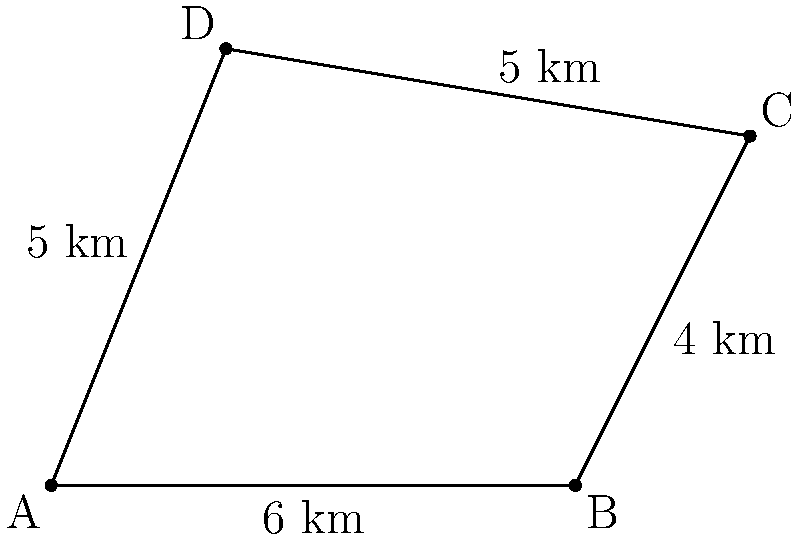An irregularly shaped land parcel for a potential airport expansion is represented by the quadrilateral ABCD in the diagram. Given that AB = 6 km, BC = 4 km, CD = 5 km, and DA = 5 km, calculate the area of this land parcel using the vector method. Round your answer to the nearest square kilometer. To calculate the area of the quadrilateral using the vector method, we'll follow these steps:

1) Choose a reference point (e.g., point A) and express other points as vectors from A:
   $\vec{AB} = (6,0)$
   $\vec{AC} = (8,4)$
   $\vec{AD} = (2,5)$

2) The area of a quadrilateral ABCD can be calculated using the formula:
   Area = $\frac{1}{2}|(\vec{AB} \times \vec{AC}) + (\vec{AC} \times \vec{AD})|$

3) Calculate the cross products:
   $\vec{AB} \times \vec{AC} = (6 \cdot 4) - (0 \cdot 8) = 24$
   $\vec{AC} \times \vec{AD} = (8 \cdot 5) - (4 \cdot 2) = 32$

4) Sum the cross products:
   $24 + 32 = 56$

5) Multiply by $\frac{1}{2}$:
   $\frac{1}{2} \cdot 56 = 28$

6) The exact area is 28 sq km.

7) Rounding to the nearest square kilometer, the answer is 28 sq km.
Answer: 28 sq km 